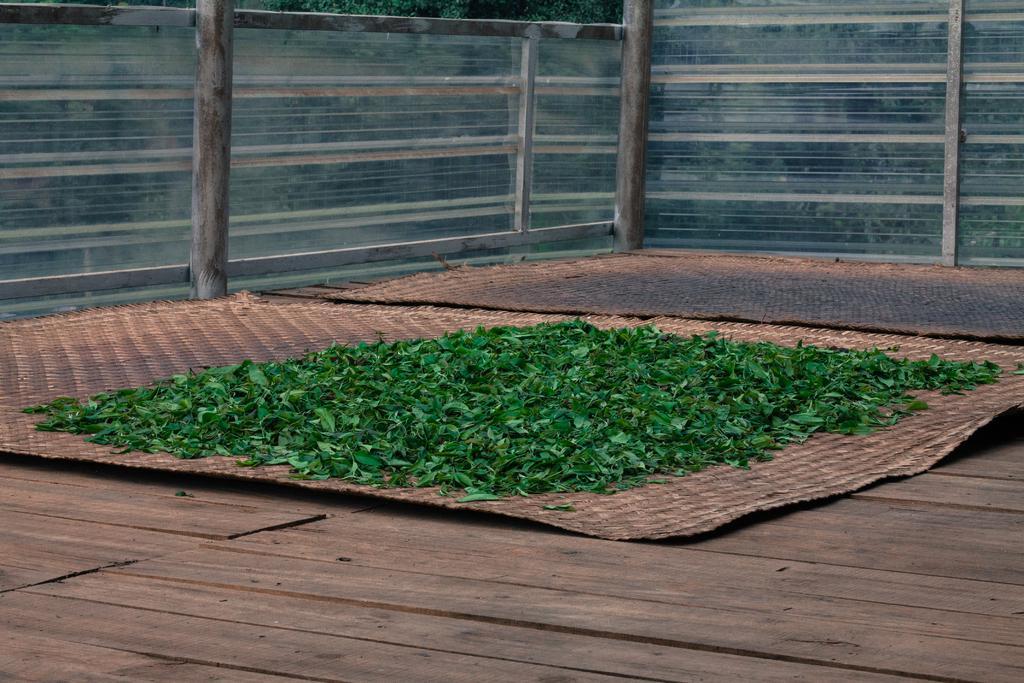Can you describe this image briefly? In this image there are leaves on a mat, the mat is on the wooden platform, in the background of the image there is a glass fence supported by metal rods. 